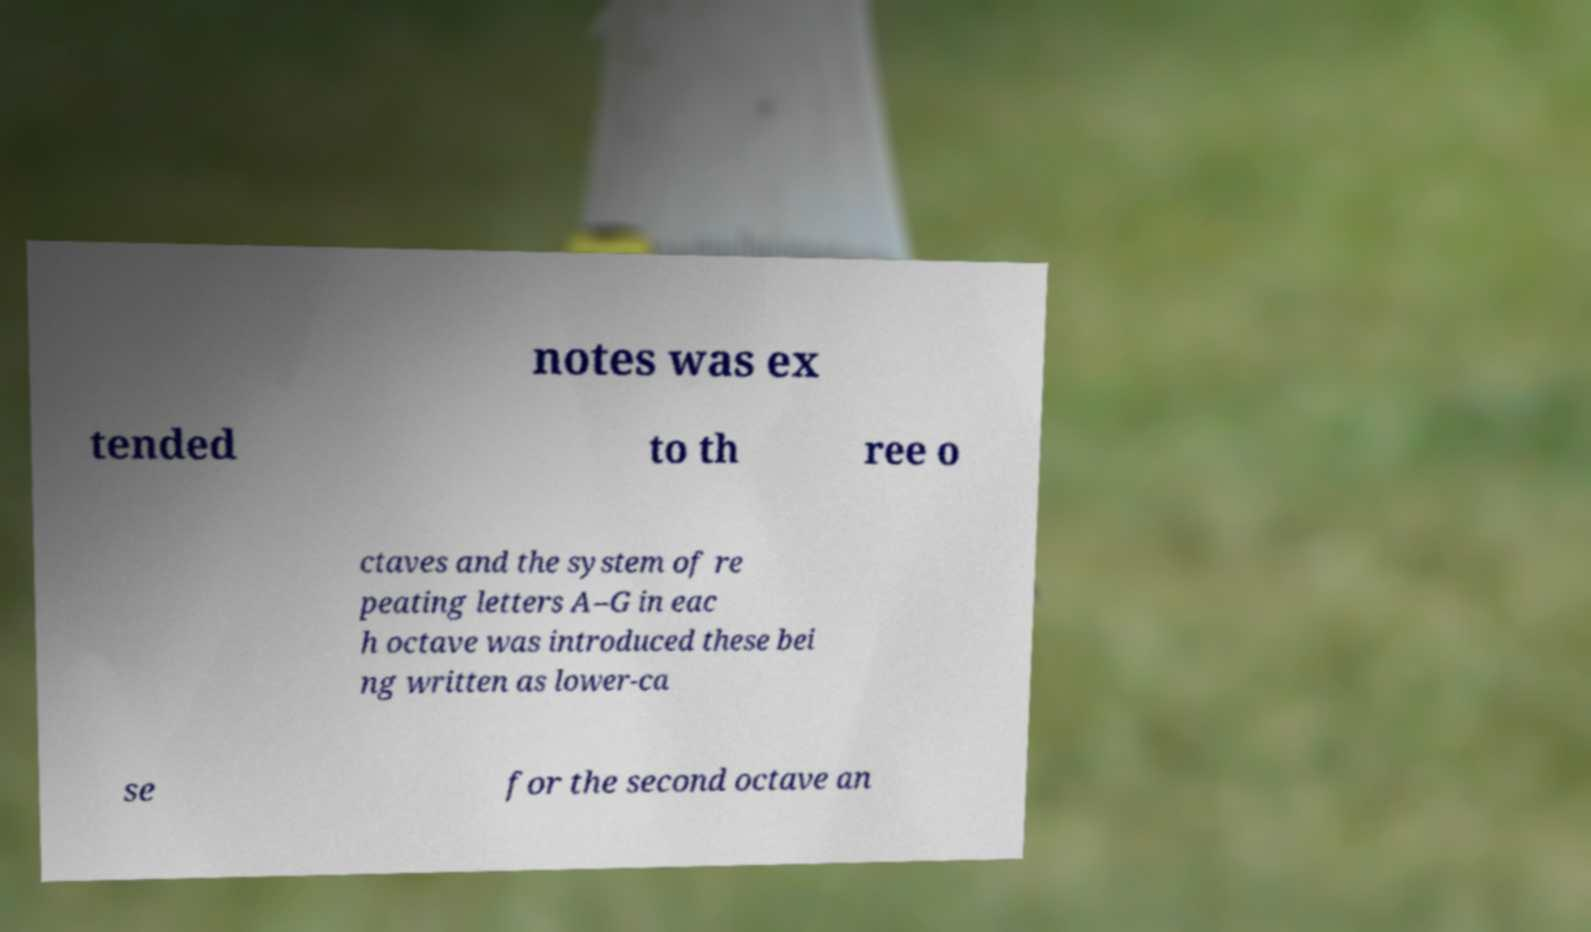What messages or text are displayed in this image? I need them in a readable, typed format. notes was ex tended to th ree o ctaves and the system of re peating letters A–G in eac h octave was introduced these bei ng written as lower-ca se for the second octave an 